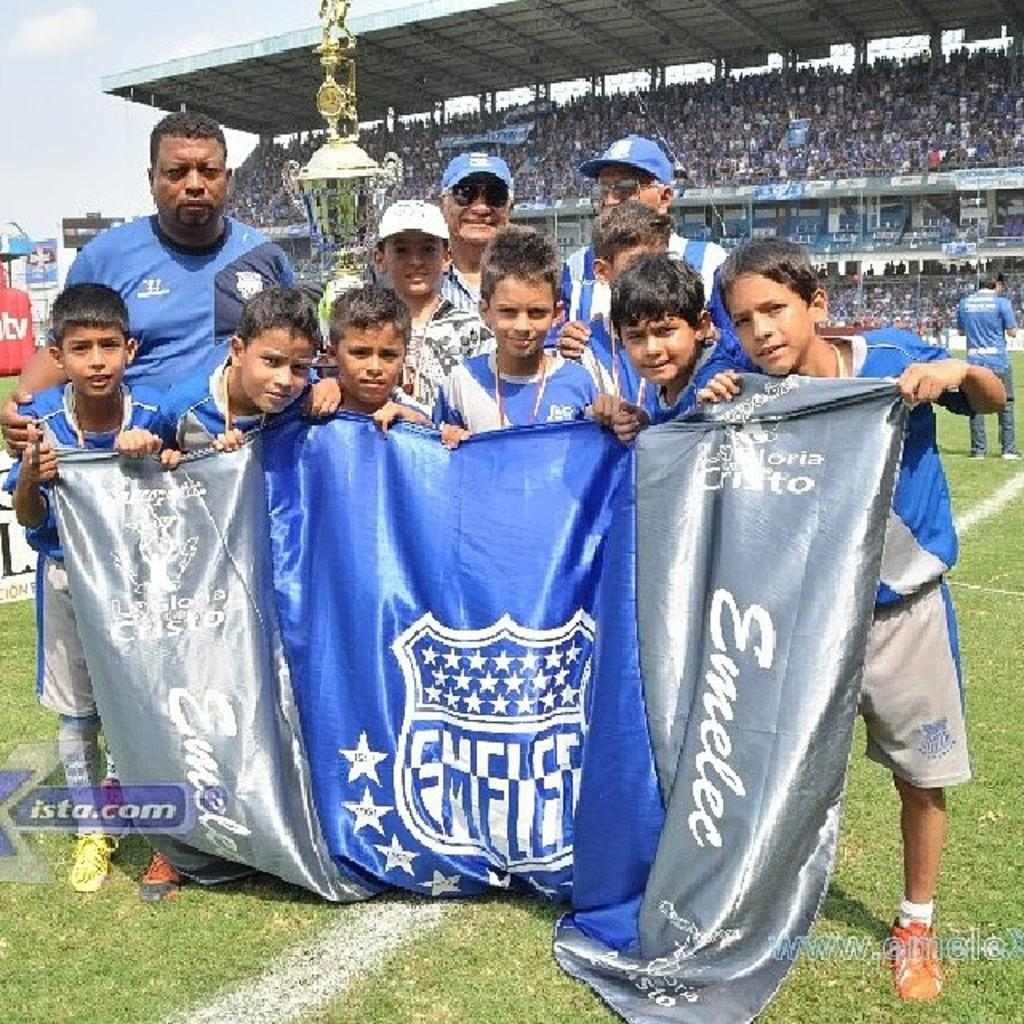<image>
Give a short and clear explanation of the subsequent image. a small group of a boy's sports team holding a blue and silver banner that says Emelec on the field with fans in the stands behind them. 